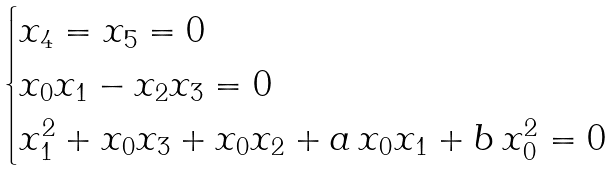<formula> <loc_0><loc_0><loc_500><loc_500>\begin{cases} x _ { 4 } = x _ { 5 } = 0 \\ x _ { 0 } x _ { 1 } - x _ { 2 } x _ { 3 } = 0 \\ x _ { 1 } ^ { 2 } + x _ { 0 } x _ { 3 } + x _ { 0 } x _ { 2 } + a \, x _ { 0 } x _ { 1 } + b \, x _ { 0 } ^ { 2 } = 0 \end{cases}</formula> 